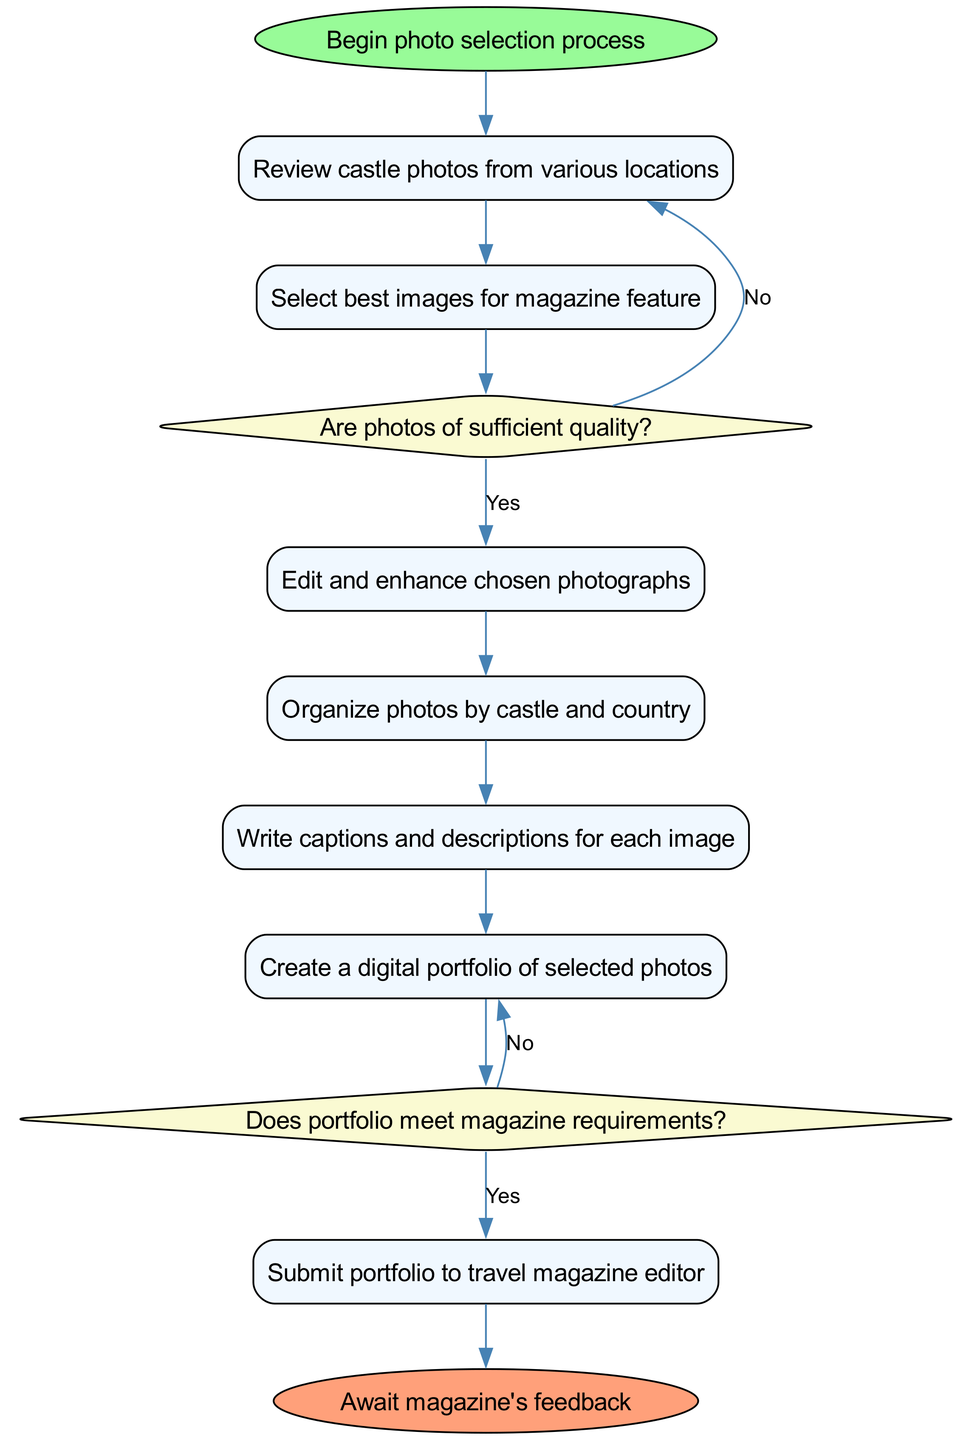What's the starting activity in the diagram? The diagram begins with the node labeled "Begin photo selection process," indicating the first action taken in the workflow.
Answer: Begin photo selection process How many decisions are present in the diagram? The diagram has two decision nodes, each representing a point in the process where a choice must be made regarding photo quality and portfolio requirements.
Answer: 2 What is the first activity after the start node? The first activity that follows the start node is "Review castle photos from various locations," outlining the initial step in the photography process.
Answer: Review castle photos from various locations What happens if the photos are not of sufficient quality? If the photos do not meet the quality requirements, the workflow indicates "Reshoot or select alternative images," which is the response to the decision made at that point.
Answer: Reshoot or select alternative images Which activity comes before the "Submit portfolio to travel magazine editor"? The activity that occurs directly before submitting the portfolio is "Create a digital portfolio of selected photos," which involves compiling the finalized images for submission.
Answer: Create a digital portfolio of selected photos If the portfolio does not meet magazine requirements, what is the next step? The next step, if the portfolio does not meet requirements, is to "Revise portfolio," as indicated by the decision process outlined in the diagram.
Answer: Revise portfolio What type of node is used for activities in the diagram? The diagram uses rectangle nodes to represent activities, distinguishing them visually from decision points, which are represented by diamond nodes.
Answer: Rectangle Which activity involves enhancing the photographs? The activity focused on enhancing the photographs is "Edit and enhance chosen photographs," placed after the selection of the best images.
Answer: Edit and enhance chosen photographs What is the final step in the diagram? The final step in the process is labeled "Await magazine's feedback," indicating that the photographer must now wait for the editor's response after submission.
Answer: Await magazine's feedback 